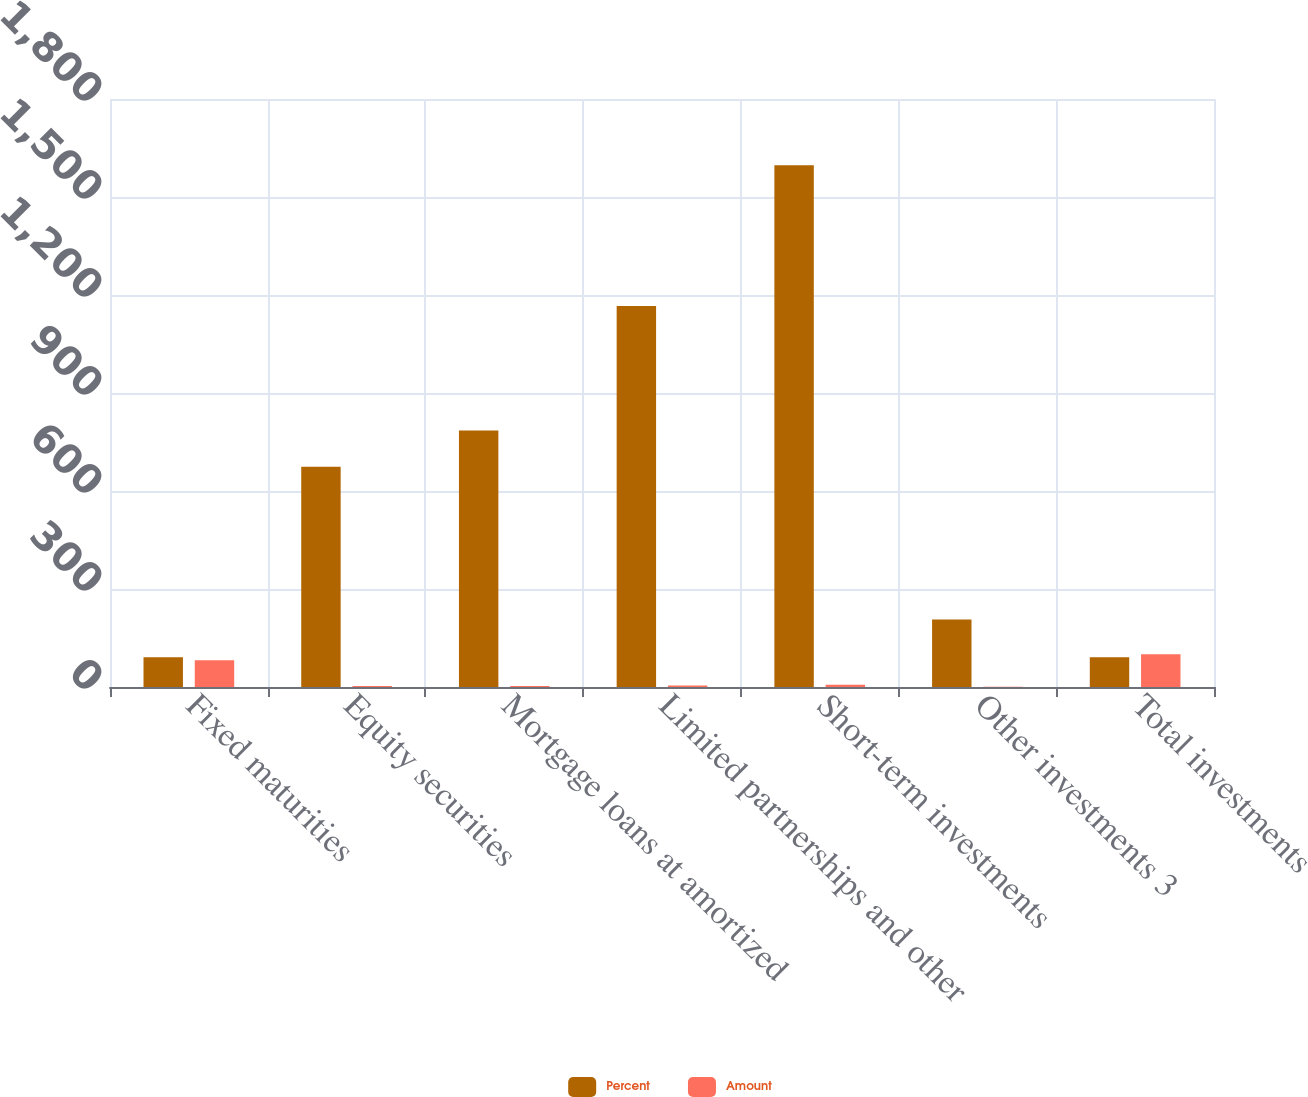<chart> <loc_0><loc_0><loc_500><loc_500><stacked_bar_chart><ecel><fcel>Fixed maturities<fcel>Equity securities<fcel>Mortgage loans at amortized<fcel>Limited partnerships and other<fcel>Short-term investments<fcel>Other investments 3<fcel>Total investments<nl><fcel>Percent<fcel>90.85<fcel>674<fcel>785<fcel>1166<fcel>1597<fcel>207<fcel>90.85<nl><fcel>Amount<fcel>81.7<fcel>2.8<fcel>3.2<fcel>4.8<fcel>6.6<fcel>0.9<fcel>100<nl></chart> 